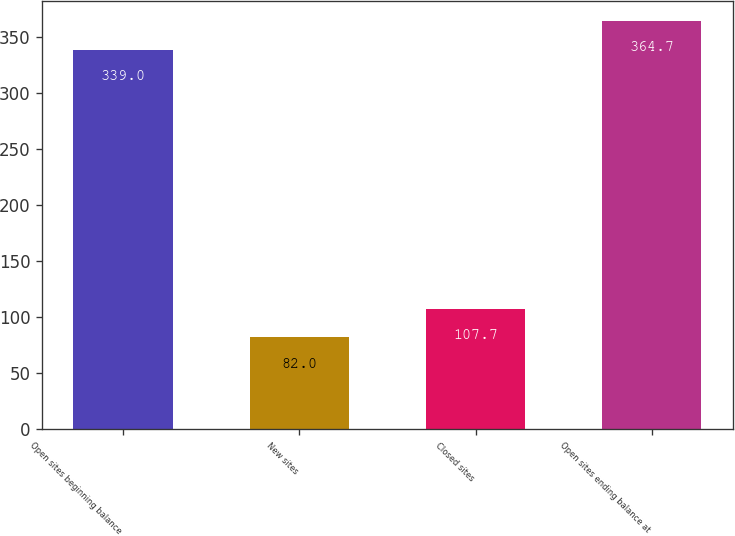Convert chart to OTSL. <chart><loc_0><loc_0><loc_500><loc_500><bar_chart><fcel>Open sites beginning balance<fcel>New sites<fcel>Closed sites<fcel>Open sites ending balance at<nl><fcel>339<fcel>82<fcel>107.7<fcel>364.7<nl></chart> 